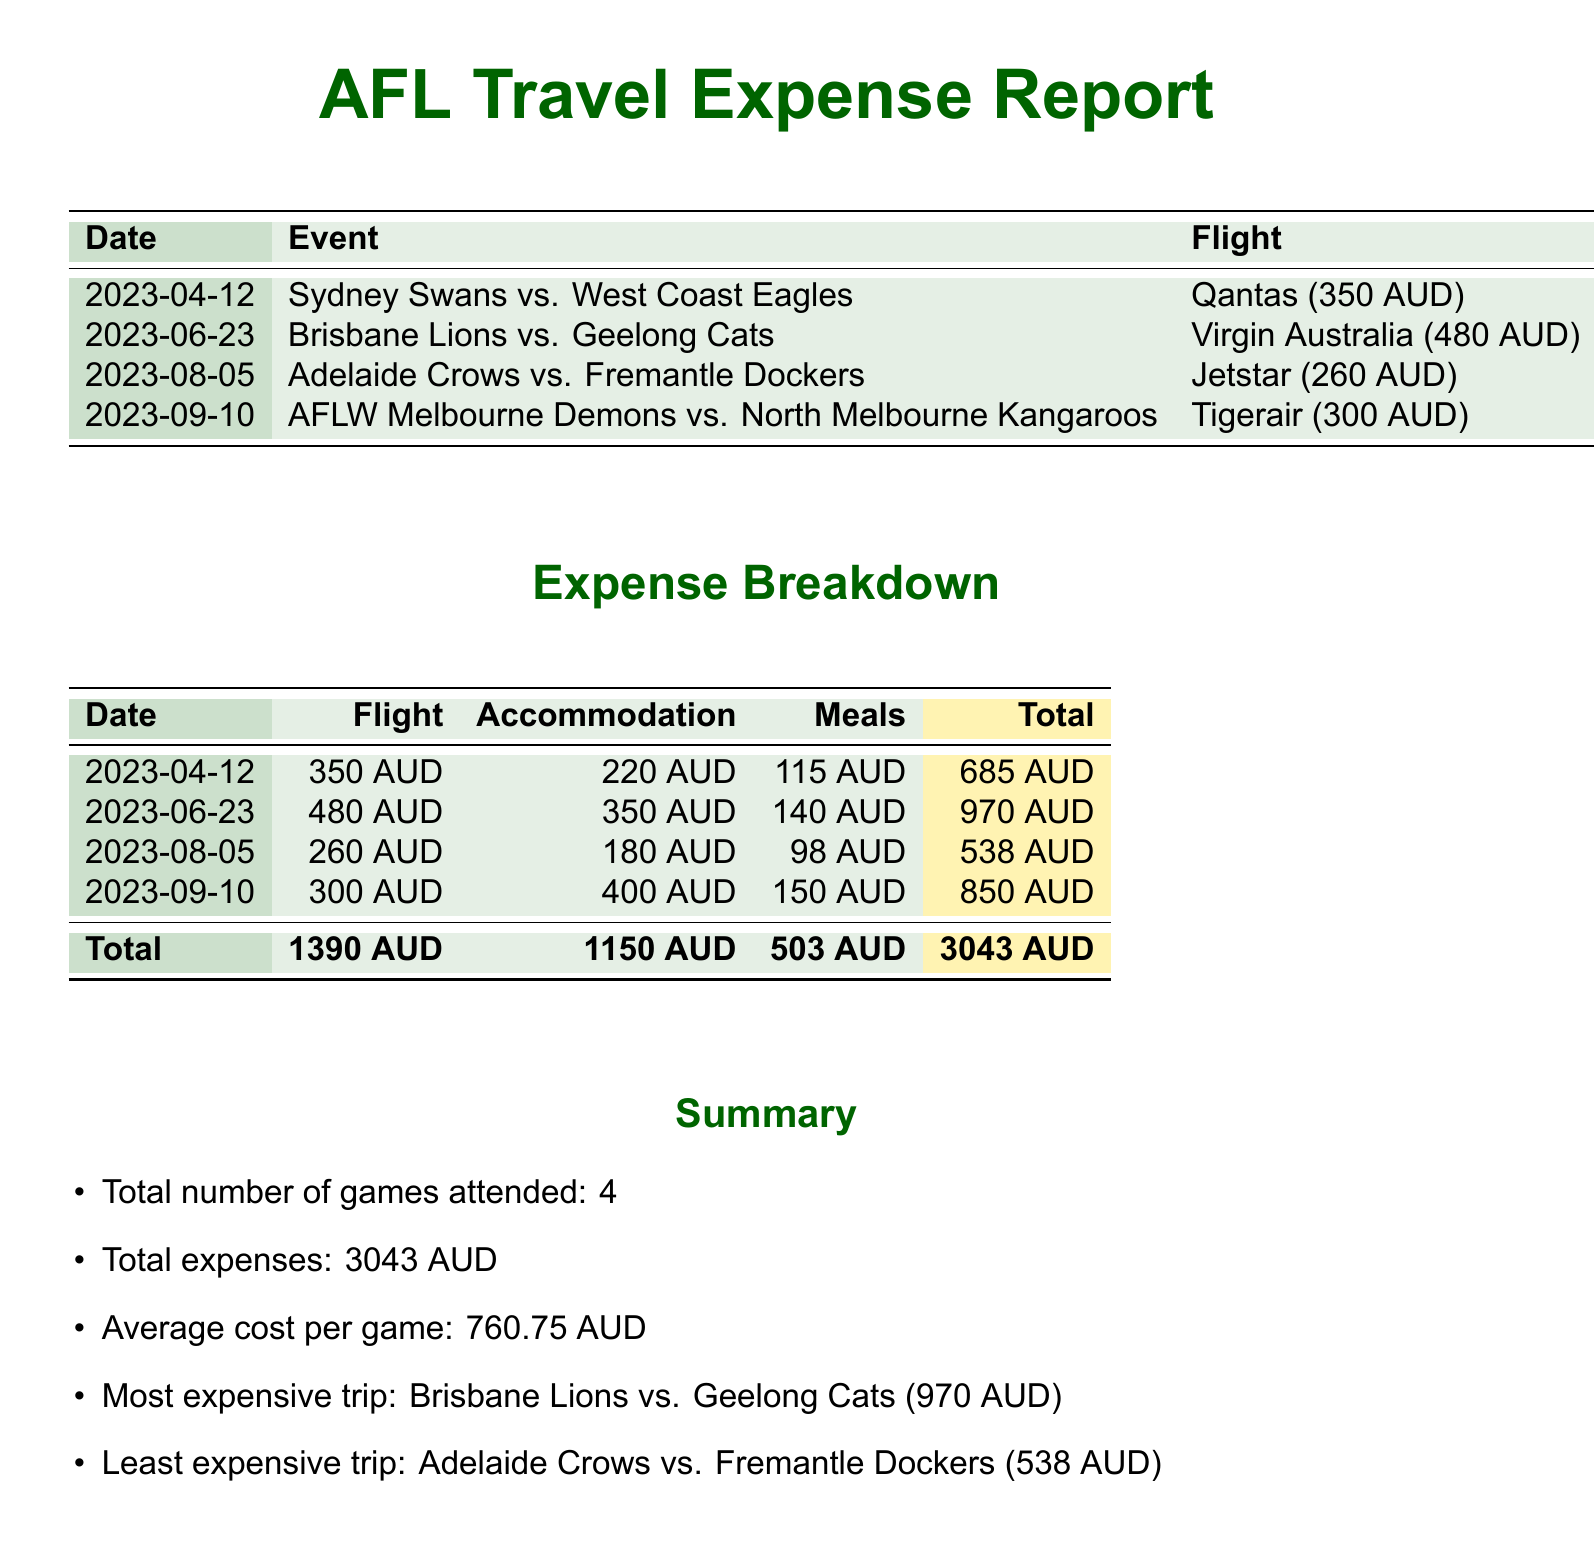What is the total number of games attended? The total number of games attended is listed in the summary section of the document.
Answer: 4 What was the total expense for flights? The total expense for flights is the sum of all flight costs provided in the breakdown section.
Answer: 1390 AUD Which event had the highest total cost? The event with the highest total cost is indicated in the summary section.
Answer: Brisbane Lions vs. Geelong Cats What was the cost of accommodation for the Adelaide Crows vs. Fremantle Dockers game? The cost of accommodation for this game is specified in the breakdown table.
Answer: 180 AUD What is the average cost per game? The average cost per game is calculated in the summary section as total expenses divided by the number of games attended.
Answer: 760.75 AUD What was the meal expense for the Sydney Swans vs. West Coast Eagles game? The meal expense for this game is provided in the expense breakdown.
Answer: 115 AUD What is the total accommodation expense? The total accommodation expense is the sum of all accommodation costs, which is found in the summary section.
Answer: 1150 AUD What airline was used for the flights to the Brisbane Lions vs. Geelong Cats game? The airline used for this flight is mentioned in the event list.
Answer: Virgin Australia What is the total cost for meals across all events? The total cost for meals is listed in the expense breakdown as the sum of all meal expenses.
Answer: 503 AUD 